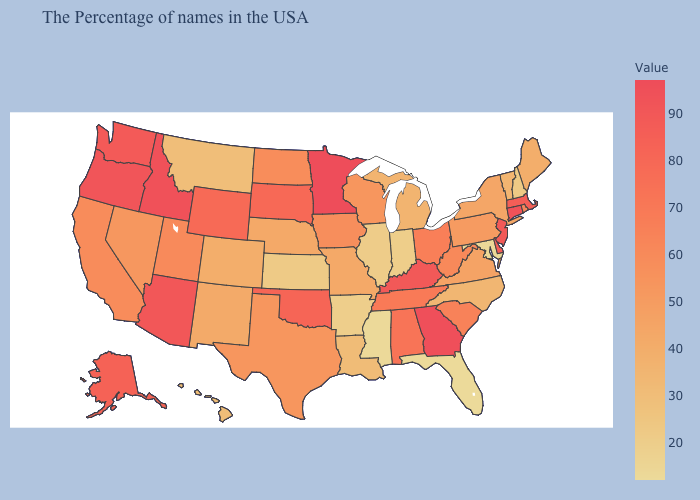Does Minnesota have the highest value in the MidWest?
Give a very brief answer. Yes. Is the legend a continuous bar?
Give a very brief answer. Yes. Does Minnesota have the highest value in the USA?
Short answer required. Yes. Which states have the highest value in the USA?
Write a very short answer. Minnesota. Does Minnesota have the highest value in the USA?
Answer briefly. Yes. 